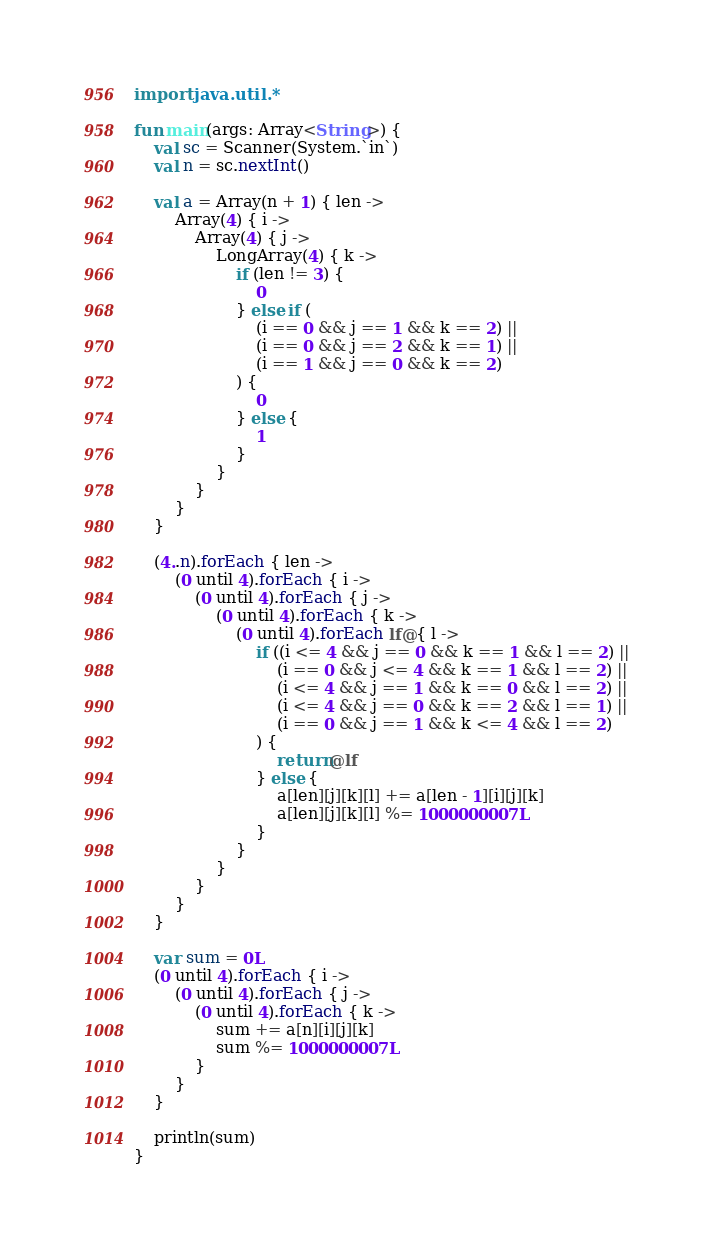<code> <loc_0><loc_0><loc_500><loc_500><_Kotlin_>import java.util.*

fun main(args: Array<String>) {
    val sc = Scanner(System.`in`)
    val n = sc.nextInt()

    val a = Array(n + 1) { len ->
        Array(4) { i ->
            Array(4) { j ->
                LongArray(4) { k ->
                    if (len != 3) {
                        0
                    } else if (
                        (i == 0 && j == 1 && k == 2) ||
                        (i == 0 && j == 2 && k == 1) ||
                        (i == 1 && j == 0 && k == 2)
                    ) {
                        0
                    } else {
                        1
                    }
                }
            }
        }
    }

    (4..n).forEach { len ->
        (0 until 4).forEach { i ->
            (0 until 4).forEach { j ->
                (0 until 4).forEach { k ->
                    (0 until 4).forEach lf@{ l ->
                        if ((i <= 4 && j == 0 && k == 1 && l == 2) ||
                            (i == 0 && j <= 4 && k == 1 && l == 2) ||
                            (i <= 4 && j == 1 && k == 0 && l == 2) ||
                            (i <= 4 && j == 0 && k == 2 && l == 1) ||
                            (i == 0 && j == 1 && k <= 4 && l == 2)
                        ) {
                            return@lf
                        } else {
                            a[len][j][k][l] += a[len - 1][i][j][k]
                            a[len][j][k][l] %= 1000000007L
                        }
                    }
                }
            }
        }
    }

    var sum = 0L
    (0 until 4).forEach { i ->
        (0 until 4).forEach { j ->
            (0 until 4).forEach { k ->
                sum += a[n][i][j][k]
                sum %= 1000000007L
            }
        }
    }

    println(sum)
}</code> 